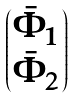Convert formula to latex. <formula><loc_0><loc_0><loc_500><loc_500>\begin{pmatrix} \bar { \Phi } _ { 1 } \\ \bar { \Phi } _ { 2 } \end{pmatrix}</formula> 